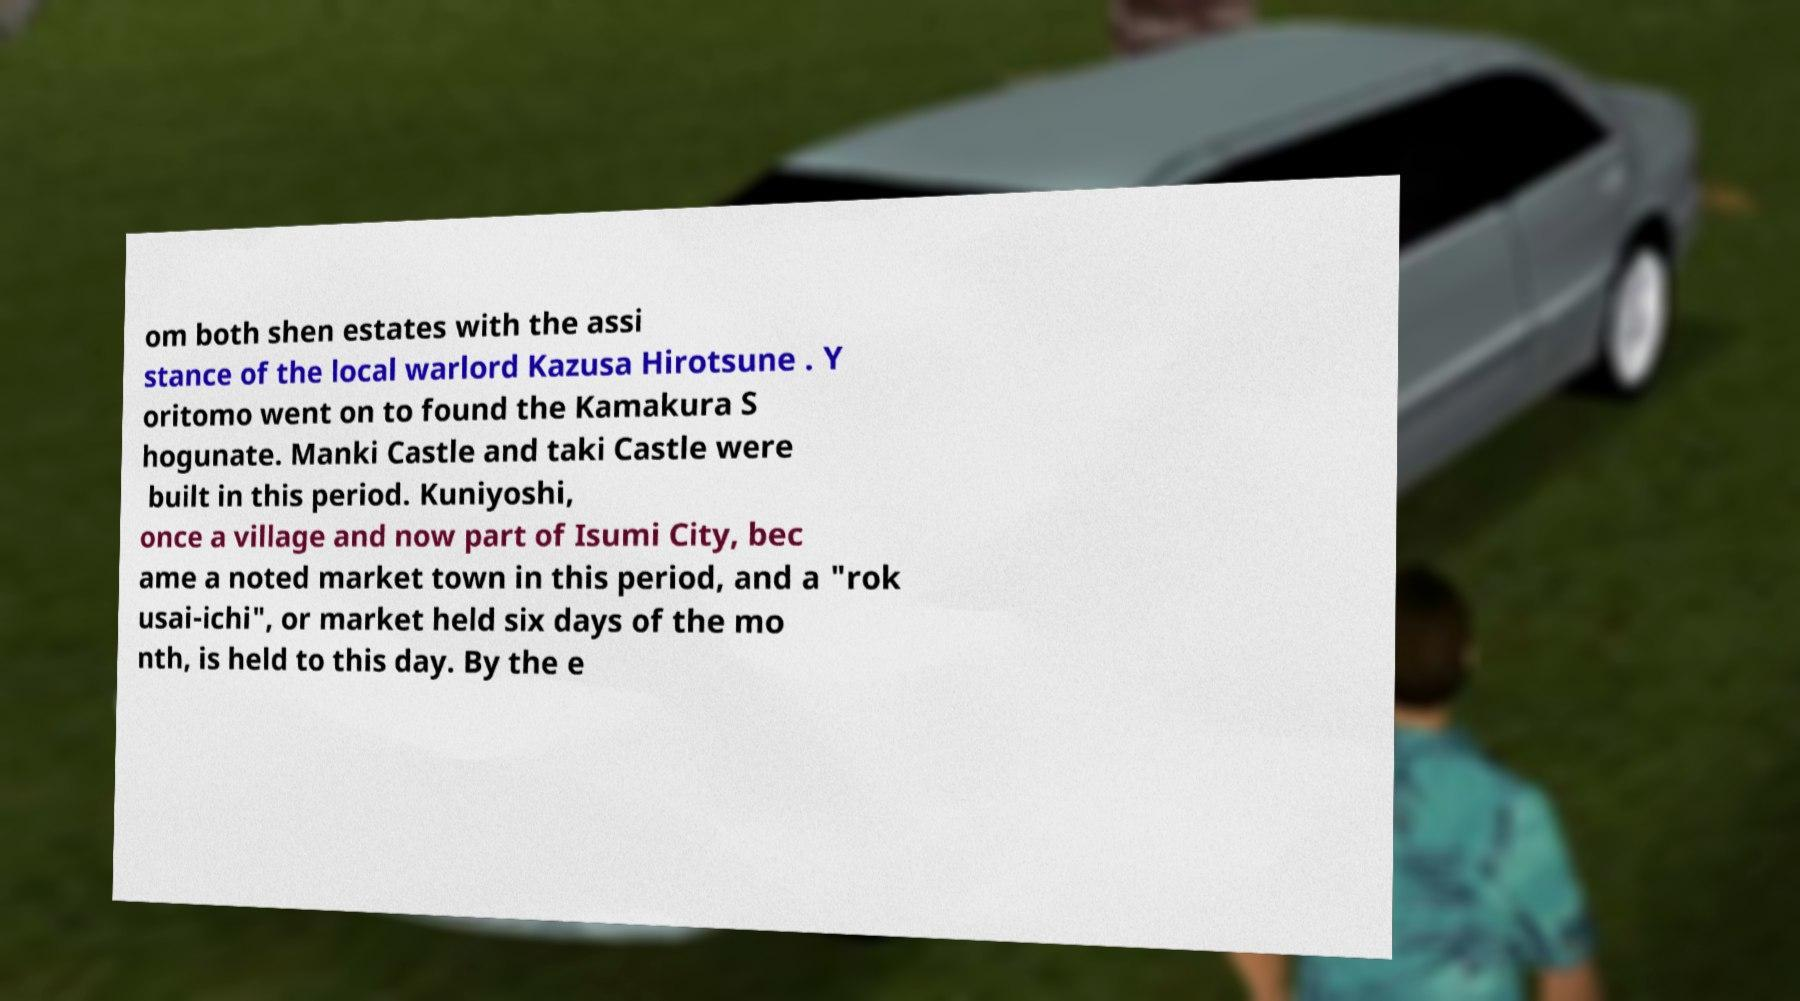What messages or text are displayed in this image? I need them in a readable, typed format. om both shen estates with the assi stance of the local warlord Kazusa Hirotsune . Y oritomo went on to found the Kamakura S hogunate. Manki Castle and taki Castle were built in this period. Kuniyoshi, once a village and now part of Isumi City, bec ame a noted market town in this period, and a "rok usai-ichi", or market held six days of the mo nth, is held to this day. By the e 